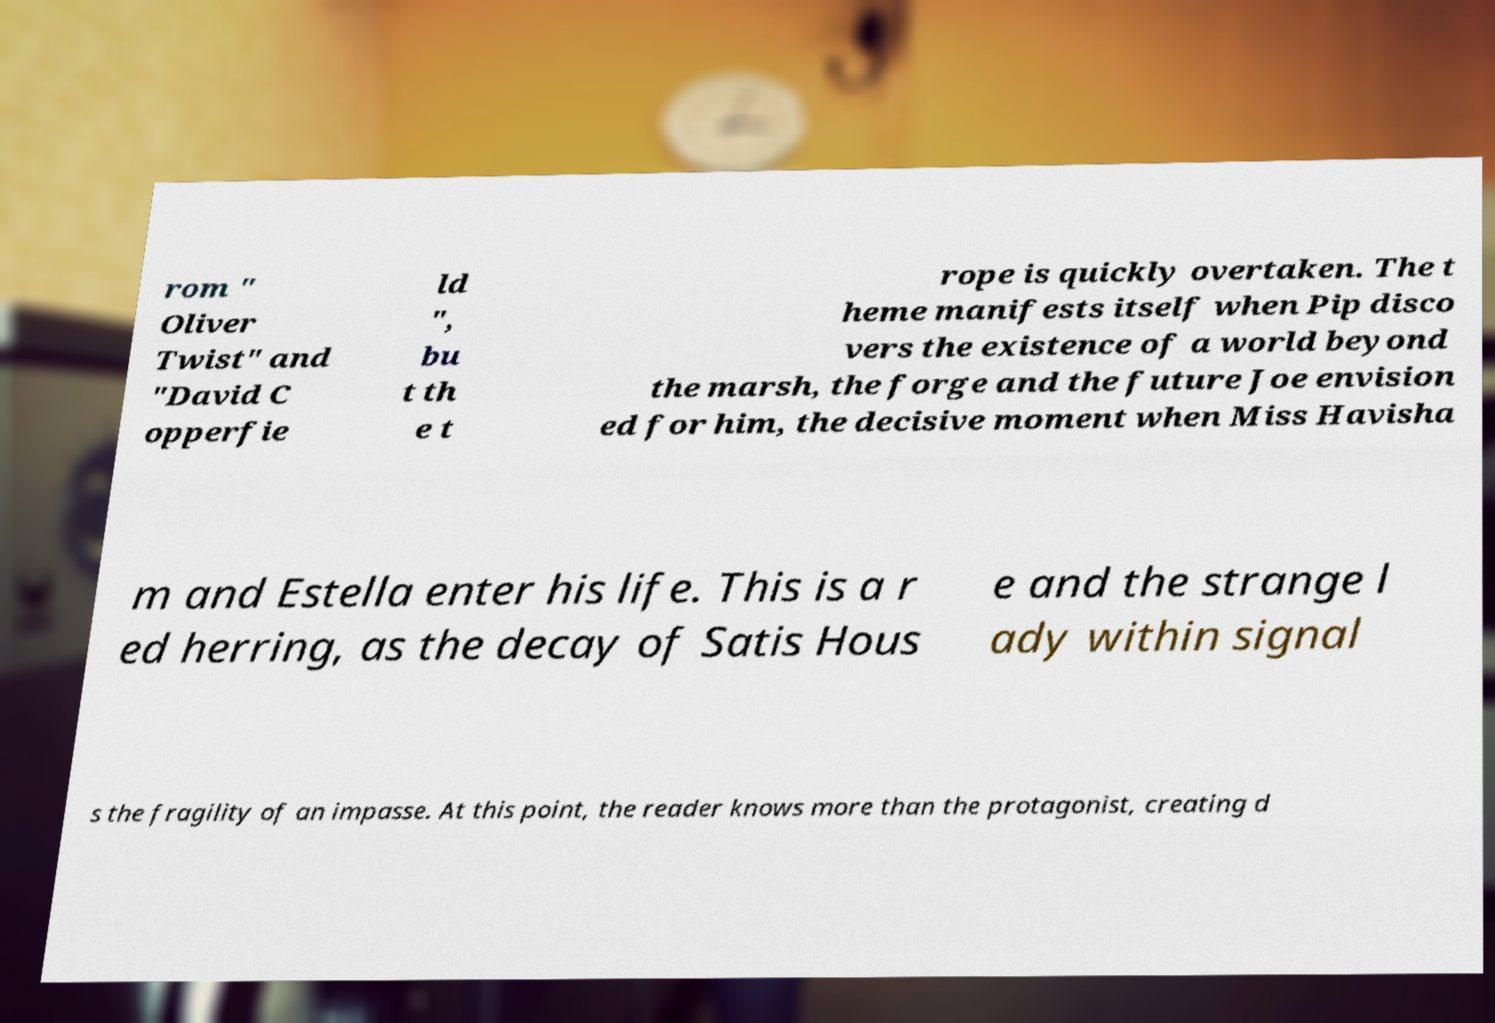Please identify and transcribe the text found in this image. rom " Oliver Twist" and "David C opperfie ld ", bu t th e t rope is quickly overtaken. The t heme manifests itself when Pip disco vers the existence of a world beyond the marsh, the forge and the future Joe envision ed for him, the decisive moment when Miss Havisha m and Estella enter his life. This is a r ed herring, as the decay of Satis Hous e and the strange l ady within signal s the fragility of an impasse. At this point, the reader knows more than the protagonist, creating d 